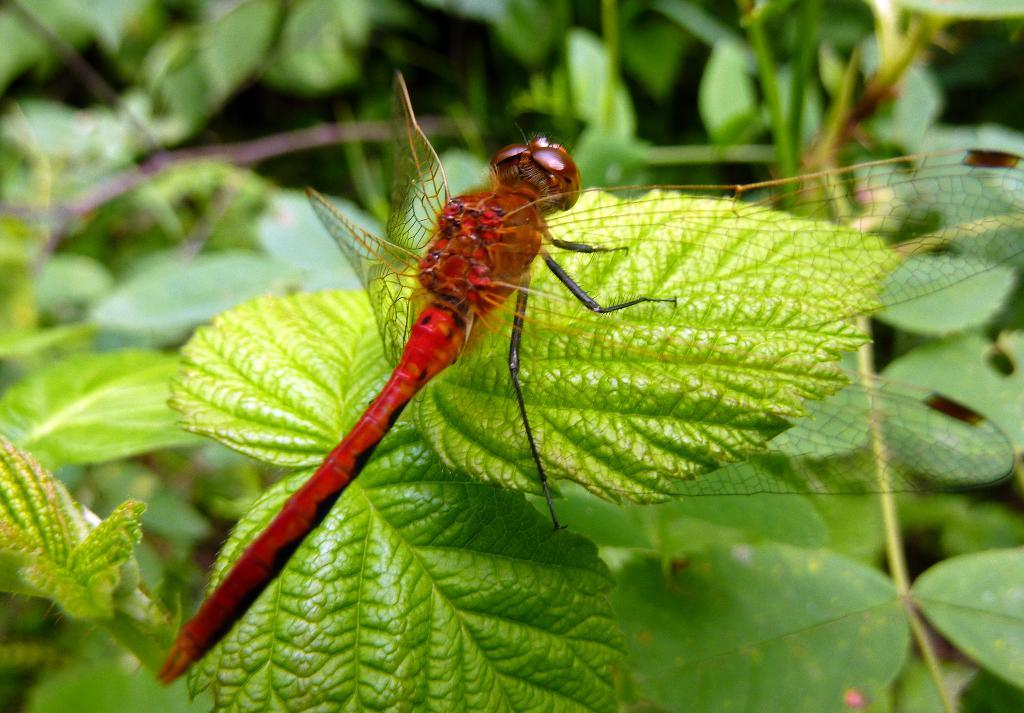What is the main subject in the center of the image? There is a fly in the center of the image. What can be seen in the background of the image? There are plants in the background of the image. What type of carriage is being pulled by the horse in the image? There is no carriage or horse present in the image; it only features a fly and plants in the background. What card game is being played in the image? There is no card game or cards present in the image; it only features a fly and plants in the background. 